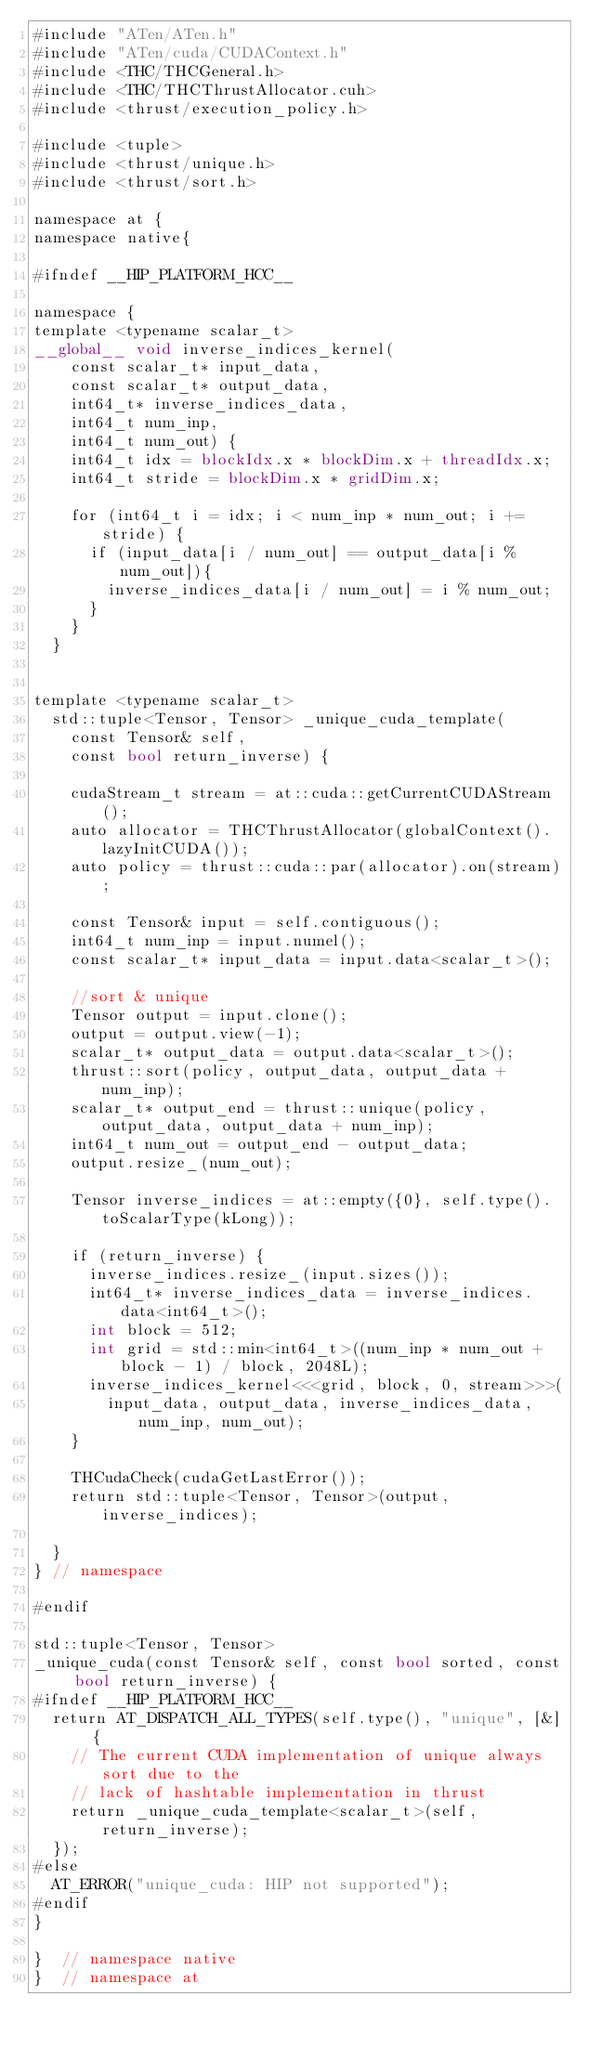<code> <loc_0><loc_0><loc_500><loc_500><_Cuda_>#include "ATen/ATen.h"
#include "ATen/cuda/CUDAContext.h"
#include <THC/THCGeneral.h>
#include <THC/THCThrustAllocator.cuh>
#include <thrust/execution_policy.h>

#include <tuple>
#include <thrust/unique.h>
#include <thrust/sort.h>

namespace at {
namespace native{

#ifndef __HIP_PLATFORM_HCC__

namespace {
template <typename scalar_t>
__global__ void inverse_indices_kernel(
    const scalar_t* input_data,
    const scalar_t* output_data,
    int64_t* inverse_indices_data,
    int64_t num_inp,
    int64_t num_out) {
    int64_t idx = blockIdx.x * blockDim.x + threadIdx.x;
    int64_t stride = blockDim.x * gridDim.x;

    for (int64_t i = idx; i < num_inp * num_out; i += stride) {
      if (input_data[i / num_out] == output_data[i % num_out]){
        inverse_indices_data[i / num_out] = i % num_out;   
      }
    }
  }


template <typename scalar_t>
  std::tuple<Tensor, Tensor> _unique_cuda_template(
    const Tensor& self,
    const bool return_inverse) {

    cudaStream_t stream = at::cuda::getCurrentCUDAStream();
    auto allocator = THCThrustAllocator(globalContext().lazyInitCUDA());
    auto policy = thrust::cuda::par(allocator).on(stream);

    const Tensor& input = self.contiguous();
    int64_t num_inp = input.numel();
    const scalar_t* input_data = input.data<scalar_t>();

    //sort & unique
    Tensor output = input.clone();
    output = output.view(-1);
    scalar_t* output_data = output.data<scalar_t>();
    thrust::sort(policy, output_data, output_data + num_inp);
    scalar_t* output_end = thrust::unique(policy, output_data, output_data + num_inp);
    int64_t num_out = output_end - output_data;
    output.resize_(num_out);

    Tensor inverse_indices = at::empty({0}, self.type().toScalarType(kLong));

    if (return_inverse) {
      inverse_indices.resize_(input.sizes());
      int64_t* inverse_indices_data = inverse_indices.data<int64_t>();
      int block = 512;
      int grid = std::min<int64_t>((num_inp * num_out + block - 1) / block, 2048L);
      inverse_indices_kernel<<<grid, block, 0, stream>>>(
        input_data, output_data, inverse_indices_data, num_inp, num_out);
    }

    THCudaCheck(cudaGetLastError());   
    return std::tuple<Tensor, Tensor>(output, inverse_indices);

  }
} // namespace

#endif

std::tuple<Tensor, Tensor>
_unique_cuda(const Tensor& self, const bool sorted, const bool return_inverse) {
#ifndef __HIP_PLATFORM_HCC__
  return AT_DISPATCH_ALL_TYPES(self.type(), "unique", [&] {
    // The current CUDA implementation of unique always sort due to the
    // lack of hashtable implementation in thrust
    return _unique_cuda_template<scalar_t>(self, return_inverse);
  });
#else
  AT_ERROR("unique_cuda: HIP not supported");
#endif
}

}  // namespace native
}  // namespace at
</code> 